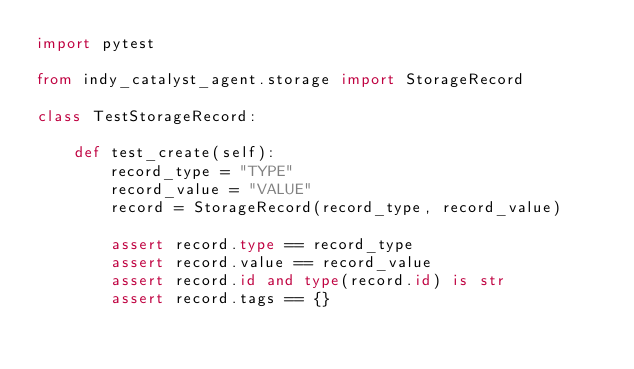Convert code to text. <code><loc_0><loc_0><loc_500><loc_500><_Python_>import pytest

from indy_catalyst_agent.storage import StorageRecord

class TestStorageRecord:

    def test_create(self):
        record_type = "TYPE"
        record_value = "VALUE"
        record = StorageRecord(record_type, record_value)

        assert record.type == record_type
        assert record.value == record_value
        assert record.id and type(record.id) is str
        assert record.tags == {}
</code> 